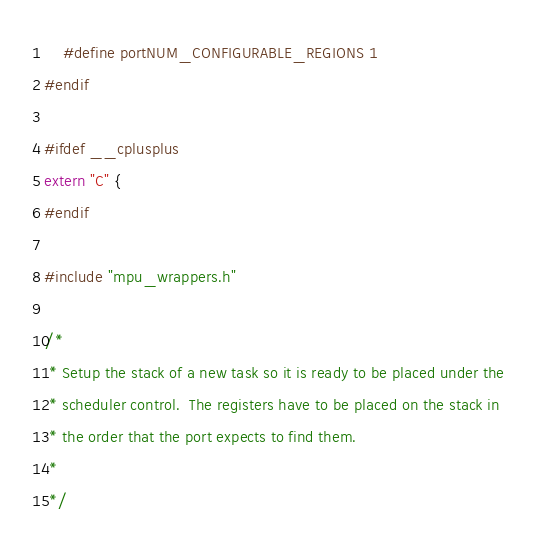<code> <loc_0><loc_0><loc_500><loc_500><_C_>	#define portNUM_CONFIGURABLE_REGIONS 1
#endif

#ifdef __cplusplus
extern "C" {
#endif

#include "mpu_wrappers.h"

/*
 * Setup the stack of a new task so it is ready to be placed under the
 * scheduler control.  The registers have to be placed on the stack in
 * the order that the port expects to find them.
 *
 */</code> 